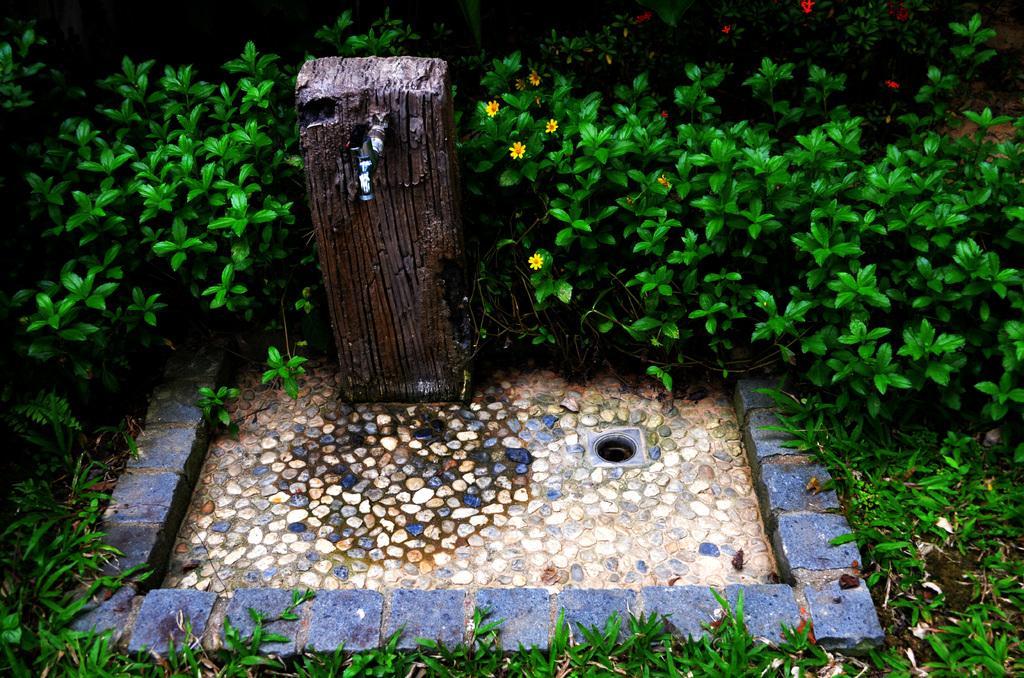Could you give a brief overview of what you see in this image? In this picture we can see an object on the ground and in the background we can see plants, flowers. 